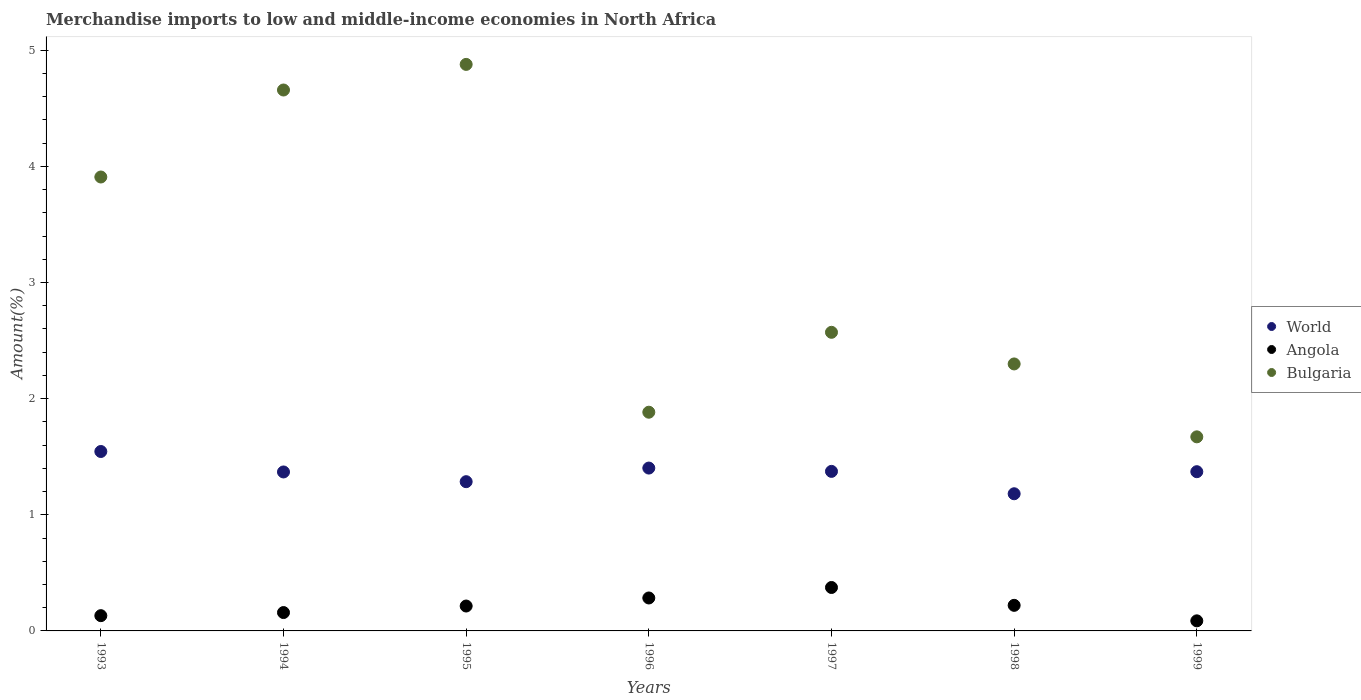Is the number of dotlines equal to the number of legend labels?
Keep it short and to the point. Yes. What is the percentage of amount earned from merchandise imports in Angola in 1993?
Your answer should be compact. 0.13. Across all years, what is the maximum percentage of amount earned from merchandise imports in Angola?
Keep it short and to the point. 0.37. Across all years, what is the minimum percentage of amount earned from merchandise imports in World?
Offer a terse response. 1.18. What is the total percentage of amount earned from merchandise imports in World in the graph?
Your answer should be compact. 9.53. What is the difference between the percentage of amount earned from merchandise imports in Bulgaria in 1998 and that in 1999?
Keep it short and to the point. 0.63. What is the difference between the percentage of amount earned from merchandise imports in Bulgaria in 1997 and the percentage of amount earned from merchandise imports in World in 1995?
Your response must be concise. 1.29. What is the average percentage of amount earned from merchandise imports in Bulgaria per year?
Your answer should be compact. 3.12. In the year 1994, what is the difference between the percentage of amount earned from merchandise imports in Angola and percentage of amount earned from merchandise imports in Bulgaria?
Provide a succinct answer. -4.5. In how many years, is the percentage of amount earned from merchandise imports in Angola greater than 1.6 %?
Your response must be concise. 0. What is the ratio of the percentage of amount earned from merchandise imports in Angola in 1994 to that in 1996?
Provide a succinct answer. 0.56. Is the difference between the percentage of amount earned from merchandise imports in Angola in 1994 and 1998 greater than the difference between the percentage of amount earned from merchandise imports in Bulgaria in 1994 and 1998?
Give a very brief answer. No. What is the difference between the highest and the second highest percentage of amount earned from merchandise imports in Angola?
Give a very brief answer. 0.09. What is the difference between the highest and the lowest percentage of amount earned from merchandise imports in Bulgaria?
Provide a short and direct response. 3.21. Is it the case that in every year, the sum of the percentage of amount earned from merchandise imports in World and percentage of amount earned from merchandise imports in Bulgaria  is greater than the percentage of amount earned from merchandise imports in Angola?
Provide a short and direct response. Yes. How many dotlines are there?
Make the answer very short. 3. How many years are there in the graph?
Offer a very short reply. 7. What is the difference between two consecutive major ticks on the Y-axis?
Provide a short and direct response. 1. Are the values on the major ticks of Y-axis written in scientific E-notation?
Make the answer very short. No. Where does the legend appear in the graph?
Your answer should be compact. Center right. How many legend labels are there?
Offer a terse response. 3. What is the title of the graph?
Your answer should be compact. Merchandise imports to low and middle-income economies in North Africa. What is the label or title of the Y-axis?
Ensure brevity in your answer.  Amount(%). What is the Amount(%) in World in 1993?
Ensure brevity in your answer.  1.54. What is the Amount(%) in Angola in 1993?
Make the answer very short. 0.13. What is the Amount(%) in Bulgaria in 1993?
Offer a terse response. 3.91. What is the Amount(%) of World in 1994?
Provide a short and direct response. 1.37. What is the Amount(%) of Angola in 1994?
Offer a terse response. 0.16. What is the Amount(%) in Bulgaria in 1994?
Provide a short and direct response. 4.66. What is the Amount(%) of World in 1995?
Your answer should be compact. 1.29. What is the Amount(%) of Angola in 1995?
Your response must be concise. 0.21. What is the Amount(%) of Bulgaria in 1995?
Your response must be concise. 4.88. What is the Amount(%) of World in 1996?
Your answer should be very brief. 1.4. What is the Amount(%) in Angola in 1996?
Offer a very short reply. 0.28. What is the Amount(%) of Bulgaria in 1996?
Make the answer very short. 1.88. What is the Amount(%) of World in 1997?
Your answer should be very brief. 1.37. What is the Amount(%) of Angola in 1997?
Your response must be concise. 0.37. What is the Amount(%) in Bulgaria in 1997?
Your response must be concise. 2.57. What is the Amount(%) in World in 1998?
Provide a succinct answer. 1.18. What is the Amount(%) in Angola in 1998?
Provide a succinct answer. 0.22. What is the Amount(%) in Bulgaria in 1998?
Offer a very short reply. 2.3. What is the Amount(%) in World in 1999?
Ensure brevity in your answer.  1.37. What is the Amount(%) in Angola in 1999?
Provide a short and direct response. 0.09. What is the Amount(%) of Bulgaria in 1999?
Your answer should be compact. 1.67. Across all years, what is the maximum Amount(%) of World?
Your response must be concise. 1.54. Across all years, what is the maximum Amount(%) of Angola?
Offer a terse response. 0.37. Across all years, what is the maximum Amount(%) of Bulgaria?
Your answer should be compact. 4.88. Across all years, what is the minimum Amount(%) in World?
Offer a very short reply. 1.18. Across all years, what is the minimum Amount(%) in Angola?
Give a very brief answer. 0.09. Across all years, what is the minimum Amount(%) in Bulgaria?
Provide a short and direct response. 1.67. What is the total Amount(%) in World in the graph?
Make the answer very short. 9.53. What is the total Amount(%) of Angola in the graph?
Your answer should be compact. 1.47. What is the total Amount(%) in Bulgaria in the graph?
Offer a very short reply. 21.87. What is the difference between the Amount(%) in World in 1993 and that in 1994?
Offer a very short reply. 0.18. What is the difference between the Amount(%) in Angola in 1993 and that in 1994?
Make the answer very short. -0.03. What is the difference between the Amount(%) of Bulgaria in 1993 and that in 1994?
Make the answer very short. -0.75. What is the difference between the Amount(%) of World in 1993 and that in 1995?
Your response must be concise. 0.26. What is the difference between the Amount(%) in Angola in 1993 and that in 1995?
Offer a very short reply. -0.08. What is the difference between the Amount(%) of Bulgaria in 1993 and that in 1995?
Make the answer very short. -0.97. What is the difference between the Amount(%) in World in 1993 and that in 1996?
Your answer should be very brief. 0.14. What is the difference between the Amount(%) in Angola in 1993 and that in 1996?
Give a very brief answer. -0.15. What is the difference between the Amount(%) in Bulgaria in 1993 and that in 1996?
Provide a short and direct response. 2.03. What is the difference between the Amount(%) of World in 1993 and that in 1997?
Give a very brief answer. 0.17. What is the difference between the Amount(%) of Angola in 1993 and that in 1997?
Give a very brief answer. -0.24. What is the difference between the Amount(%) of Bulgaria in 1993 and that in 1997?
Your answer should be very brief. 1.34. What is the difference between the Amount(%) in World in 1993 and that in 1998?
Ensure brevity in your answer.  0.36. What is the difference between the Amount(%) of Angola in 1993 and that in 1998?
Offer a terse response. -0.09. What is the difference between the Amount(%) in Bulgaria in 1993 and that in 1998?
Your answer should be very brief. 1.61. What is the difference between the Amount(%) in World in 1993 and that in 1999?
Ensure brevity in your answer.  0.17. What is the difference between the Amount(%) of Angola in 1993 and that in 1999?
Offer a terse response. 0.04. What is the difference between the Amount(%) of Bulgaria in 1993 and that in 1999?
Your answer should be very brief. 2.24. What is the difference between the Amount(%) of World in 1994 and that in 1995?
Provide a short and direct response. 0.08. What is the difference between the Amount(%) in Angola in 1994 and that in 1995?
Your response must be concise. -0.06. What is the difference between the Amount(%) of Bulgaria in 1994 and that in 1995?
Your answer should be compact. -0.22. What is the difference between the Amount(%) in World in 1994 and that in 1996?
Provide a succinct answer. -0.03. What is the difference between the Amount(%) of Angola in 1994 and that in 1996?
Your answer should be very brief. -0.13. What is the difference between the Amount(%) in Bulgaria in 1994 and that in 1996?
Give a very brief answer. 2.77. What is the difference between the Amount(%) in World in 1994 and that in 1997?
Offer a terse response. -0.01. What is the difference between the Amount(%) of Angola in 1994 and that in 1997?
Your answer should be compact. -0.22. What is the difference between the Amount(%) of Bulgaria in 1994 and that in 1997?
Your answer should be compact. 2.09. What is the difference between the Amount(%) in World in 1994 and that in 1998?
Ensure brevity in your answer.  0.19. What is the difference between the Amount(%) of Angola in 1994 and that in 1998?
Make the answer very short. -0.06. What is the difference between the Amount(%) of Bulgaria in 1994 and that in 1998?
Provide a succinct answer. 2.36. What is the difference between the Amount(%) of World in 1994 and that in 1999?
Give a very brief answer. -0. What is the difference between the Amount(%) in Angola in 1994 and that in 1999?
Your answer should be very brief. 0.07. What is the difference between the Amount(%) in Bulgaria in 1994 and that in 1999?
Offer a terse response. 2.99. What is the difference between the Amount(%) of World in 1995 and that in 1996?
Your answer should be very brief. -0.12. What is the difference between the Amount(%) in Angola in 1995 and that in 1996?
Your response must be concise. -0.07. What is the difference between the Amount(%) in Bulgaria in 1995 and that in 1996?
Your answer should be compact. 2.99. What is the difference between the Amount(%) of World in 1995 and that in 1997?
Provide a short and direct response. -0.09. What is the difference between the Amount(%) of Angola in 1995 and that in 1997?
Give a very brief answer. -0.16. What is the difference between the Amount(%) of Bulgaria in 1995 and that in 1997?
Give a very brief answer. 2.31. What is the difference between the Amount(%) of World in 1995 and that in 1998?
Offer a terse response. 0.1. What is the difference between the Amount(%) in Angola in 1995 and that in 1998?
Offer a terse response. -0.01. What is the difference between the Amount(%) in Bulgaria in 1995 and that in 1998?
Give a very brief answer. 2.58. What is the difference between the Amount(%) of World in 1995 and that in 1999?
Your response must be concise. -0.09. What is the difference between the Amount(%) in Angola in 1995 and that in 1999?
Keep it short and to the point. 0.13. What is the difference between the Amount(%) in Bulgaria in 1995 and that in 1999?
Offer a terse response. 3.21. What is the difference between the Amount(%) in World in 1996 and that in 1997?
Your response must be concise. 0.03. What is the difference between the Amount(%) of Angola in 1996 and that in 1997?
Give a very brief answer. -0.09. What is the difference between the Amount(%) of Bulgaria in 1996 and that in 1997?
Give a very brief answer. -0.69. What is the difference between the Amount(%) in World in 1996 and that in 1998?
Provide a succinct answer. 0.22. What is the difference between the Amount(%) of Angola in 1996 and that in 1998?
Provide a short and direct response. 0.06. What is the difference between the Amount(%) in Bulgaria in 1996 and that in 1998?
Your answer should be compact. -0.42. What is the difference between the Amount(%) of World in 1996 and that in 1999?
Provide a succinct answer. 0.03. What is the difference between the Amount(%) of Angola in 1996 and that in 1999?
Give a very brief answer. 0.2. What is the difference between the Amount(%) of Bulgaria in 1996 and that in 1999?
Keep it short and to the point. 0.21. What is the difference between the Amount(%) of World in 1997 and that in 1998?
Keep it short and to the point. 0.19. What is the difference between the Amount(%) in Angola in 1997 and that in 1998?
Provide a succinct answer. 0.15. What is the difference between the Amount(%) in Bulgaria in 1997 and that in 1998?
Make the answer very short. 0.27. What is the difference between the Amount(%) in World in 1997 and that in 1999?
Your answer should be compact. 0. What is the difference between the Amount(%) of Angola in 1997 and that in 1999?
Your response must be concise. 0.29. What is the difference between the Amount(%) in Bulgaria in 1997 and that in 1999?
Your answer should be compact. 0.9. What is the difference between the Amount(%) in World in 1998 and that in 1999?
Offer a terse response. -0.19. What is the difference between the Amount(%) of Angola in 1998 and that in 1999?
Offer a very short reply. 0.13. What is the difference between the Amount(%) of Bulgaria in 1998 and that in 1999?
Make the answer very short. 0.63. What is the difference between the Amount(%) of World in 1993 and the Amount(%) of Angola in 1994?
Ensure brevity in your answer.  1.39. What is the difference between the Amount(%) in World in 1993 and the Amount(%) in Bulgaria in 1994?
Ensure brevity in your answer.  -3.11. What is the difference between the Amount(%) in Angola in 1993 and the Amount(%) in Bulgaria in 1994?
Your answer should be compact. -4.53. What is the difference between the Amount(%) of World in 1993 and the Amount(%) of Angola in 1995?
Ensure brevity in your answer.  1.33. What is the difference between the Amount(%) of World in 1993 and the Amount(%) of Bulgaria in 1995?
Your response must be concise. -3.33. What is the difference between the Amount(%) in Angola in 1993 and the Amount(%) in Bulgaria in 1995?
Offer a terse response. -4.75. What is the difference between the Amount(%) of World in 1993 and the Amount(%) of Angola in 1996?
Give a very brief answer. 1.26. What is the difference between the Amount(%) in World in 1993 and the Amount(%) in Bulgaria in 1996?
Ensure brevity in your answer.  -0.34. What is the difference between the Amount(%) of Angola in 1993 and the Amount(%) of Bulgaria in 1996?
Ensure brevity in your answer.  -1.75. What is the difference between the Amount(%) of World in 1993 and the Amount(%) of Angola in 1997?
Give a very brief answer. 1.17. What is the difference between the Amount(%) of World in 1993 and the Amount(%) of Bulgaria in 1997?
Offer a terse response. -1.03. What is the difference between the Amount(%) in Angola in 1993 and the Amount(%) in Bulgaria in 1997?
Give a very brief answer. -2.44. What is the difference between the Amount(%) in World in 1993 and the Amount(%) in Angola in 1998?
Provide a short and direct response. 1.32. What is the difference between the Amount(%) of World in 1993 and the Amount(%) of Bulgaria in 1998?
Make the answer very short. -0.75. What is the difference between the Amount(%) of Angola in 1993 and the Amount(%) of Bulgaria in 1998?
Your response must be concise. -2.17. What is the difference between the Amount(%) in World in 1993 and the Amount(%) in Angola in 1999?
Your response must be concise. 1.46. What is the difference between the Amount(%) in World in 1993 and the Amount(%) in Bulgaria in 1999?
Offer a terse response. -0.13. What is the difference between the Amount(%) of Angola in 1993 and the Amount(%) of Bulgaria in 1999?
Offer a very short reply. -1.54. What is the difference between the Amount(%) of World in 1994 and the Amount(%) of Angola in 1995?
Offer a very short reply. 1.15. What is the difference between the Amount(%) of World in 1994 and the Amount(%) of Bulgaria in 1995?
Make the answer very short. -3.51. What is the difference between the Amount(%) of Angola in 1994 and the Amount(%) of Bulgaria in 1995?
Provide a short and direct response. -4.72. What is the difference between the Amount(%) of World in 1994 and the Amount(%) of Angola in 1996?
Keep it short and to the point. 1.09. What is the difference between the Amount(%) in World in 1994 and the Amount(%) in Bulgaria in 1996?
Your answer should be very brief. -0.51. What is the difference between the Amount(%) in Angola in 1994 and the Amount(%) in Bulgaria in 1996?
Your answer should be very brief. -1.73. What is the difference between the Amount(%) in World in 1994 and the Amount(%) in Bulgaria in 1997?
Provide a succinct answer. -1.2. What is the difference between the Amount(%) in Angola in 1994 and the Amount(%) in Bulgaria in 1997?
Keep it short and to the point. -2.41. What is the difference between the Amount(%) of World in 1994 and the Amount(%) of Angola in 1998?
Make the answer very short. 1.15. What is the difference between the Amount(%) in World in 1994 and the Amount(%) in Bulgaria in 1998?
Provide a succinct answer. -0.93. What is the difference between the Amount(%) in Angola in 1994 and the Amount(%) in Bulgaria in 1998?
Offer a terse response. -2.14. What is the difference between the Amount(%) in World in 1994 and the Amount(%) in Angola in 1999?
Your answer should be very brief. 1.28. What is the difference between the Amount(%) of World in 1994 and the Amount(%) of Bulgaria in 1999?
Give a very brief answer. -0.3. What is the difference between the Amount(%) of Angola in 1994 and the Amount(%) of Bulgaria in 1999?
Keep it short and to the point. -1.51. What is the difference between the Amount(%) in World in 1995 and the Amount(%) in Angola in 1996?
Ensure brevity in your answer.  1. What is the difference between the Amount(%) of World in 1995 and the Amount(%) of Bulgaria in 1996?
Your answer should be compact. -0.6. What is the difference between the Amount(%) in Angola in 1995 and the Amount(%) in Bulgaria in 1996?
Provide a short and direct response. -1.67. What is the difference between the Amount(%) in World in 1995 and the Amount(%) in Angola in 1997?
Give a very brief answer. 0.91. What is the difference between the Amount(%) of World in 1995 and the Amount(%) of Bulgaria in 1997?
Offer a terse response. -1.29. What is the difference between the Amount(%) of Angola in 1995 and the Amount(%) of Bulgaria in 1997?
Your answer should be compact. -2.36. What is the difference between the Amount(%) of World in 1995 and the Amount(%) of Angola in 1998?
Provide a succinct answer. 1.06. What is the difference between the Amount(%) in World in 1995 and the Amount(%) in Bulgaria in 1998?
Give a very brief answer. -1.01. What is the difference between the Amount(%) in Angola in 1995 and the Amount(%) in Bulgaria in 1998?
Your answer should be very brief. -2.08. What is the difference between the Amount(%) in World in 1995 and the Amount(%) in Angola in 1999?
Provide a succinct answer. 1.2. What is the difference between the Amount(%) of World in 1995 and the Amount(%) of Bulgaria in 1999?
Keep it short and to the point. -0.39. What is the difference between the Amount(%) in Angola in 1995 and the Amount(%) in Bulgaria in 1999?
Provide a succinct answer. -1.46. What is the difference between the Amount(%) in World in 1996 and the Amount(%) in Angola in 1997?
Provide a short and direct response. 1.03. What is the difference between the Amount(%) in World in 1996 and the Amount(%) in Bulgaria in 1997?
Ensure brevity in your answer.  -1.17. What is the difference between the Amount(%) in Angola in 1996 and the Amount(%) in Bulgaria in 1997?
Offer a very short reply. -2.29. What is the difference between the Amount(%) of World in 1996 and the Amount(%) of Angola in 1998?
Make the answer very short. 1.18. What is the difference between the Amount(%) of World in 1996 and the Amount(%) of Bulgaria in 1998?
Give a very brief answer. -0.9. What is the difference between the Amount(%) of Angola in 1996 and the Amount(%) of Bulgaria in 1998?
Keep it short and to the point. -2.02. What is the difference between the Amount(%) in World in 1996 and the Amount(%) in Angola in 1999?
Your answer should be very brief. 1.32. What is the difference between the Amount(%) in World in 1996 and the Amount(%) in Bulgaria in 1999?
Ensure brevity in your answer.  -0.27. What is the difference between the Amount(%) in Angola in 1996 and the Amount(%) in Bulgaria in 1999?
Your answer should be very brief. -1.39. What is the difference between the Amount(%) in World in 1997 and the Amount(%) in Angola in 1998?
Offer a terse response. 1.15. What is the difference between the Amount(%) of World in 1997 and the Amount(%) of Bulgaria in 1998?
Make the answer very short. -0.93. What is the difference between the Amount(%) of Angola in 1997 and the Amount(%) of Bulgaria in 1998?
Provide a succinct answer. -1.92. What is the difference between the Amount(%) in World in 1997 and the Amount(%) in Angola in 1999?
Provide a succinct answer. 1.29. What is the difference between the Amount(%) in World in 1997 and the Amount(%) in Bulgaria in 1999?
Make the answer very short. -0.3. What is the difference between the Amount(%) of Angola in 1997 and the Amount(%) of Bulgaria in 1999?
Provide a short and direct response. -1.3. What is the difference between the Amount(%) in World in 1998 and the Amount(%) in Angola in 1999?
Give a very brief answer. 1.09. What is the difference between the Amount(%) in World in 1998 and the Amount(%) in Bulgaria in 1999?
Make the answer very short. -0.49. What is the difference between the Amount(%) of Angola in 1998 and the Amount(%) of Bulgaria in 1999?
Your answer should be compact. -1.45. What is the average Amount(%) in World per year?
Make the answer very short. 1.36. What is the average Amount(%) of Angola per year?
Offer a terse response. 0.21. What is the average Amount(%) of Bulgaria per year?
Your answer should be very brief. 3.12. In the year 1993, what is the difference between the Amount(%) in World and Amount(%) in Angola?
Ensure brevity in your answer.  1.41. In the year 1993, what is the difference between the Amount(%) of World and Amount(%) of Bulgaria?
Your answer should be very brief. -2.36. In the year 1993, what is the difference between the Amount(%) in Angola and Amount(%) in Bulgaria?
Your response must be concise. -3.78. In the year 1994, what is the difference between the Amount(%) in World and Amount(%) in Angola?
Give a very brief answer. 1.21. In the year 1994, what is the difference between the Amount(%) in World and Amount(%) in Bulgaria?
Offer a terse response. -3.29. In the year 1994, what is the difference between the Amount(%) of Angola and Amount(%) of Bulgaria?
Provide a short and direct response. -4.5. In the year 1995, what is the difference between the Amount(%) in World and Amount(%) in Angola?
Make the answer very short. 1.07. In the year 1995, what is the difference between the Amount(%) of World and Amount(%) of Bulgaria?
Ensure brevity in your answer.  -3.59. In the year 1995, what is the difference between the Amount(%) of Angola and Amount(%) of Bulgaria?
Offer a very short reply. -4.66. In the year 1996, what is the difference between the Amount(%) of World and Amount(%) of Angola?
Make the answer very short. 1.12. In the year 1996, what is the difference between the Amount(%) in World and Amount(%) in Bulgaria?
Your answer should be very brief. -0.48. In the year 1996, what is the difference between the Amount(%) in Angola and Amount(%) in Bulgaria?
Your answer should be compact. -1.6. In the year 1997, what is the difference between the Amount(%) in World and Amount(%) in Bulgaria?
Provide a succinct answer. -1.2. In the year 1997, what is the difference between the Amount(%) of Angola and Amount(%) of Bulgaria?
Your answer should be very brief. -2.2. In the year 1998, what is the difference between the Amount(%) of World and Amount(%) of Angola?
Ensure brevity in your answer.  0.96. In the year 1998, what is the difference between the Amount(%) in World and Amount(%) in Bulgaria?
Offer a very short reply. -1.12. In the year 1998, what is the difference between the Amount(%) of Angola and Amount(%) of Bulgaria?
Keep it short and to the point. -2.08. In the year 1999, what is the difference between the Amount(%) of World and Amount(%) of Angola?
Provide a succinct answer. 1.28. In the year 1999, what is the difference between the Amount(%) in World and Amount(%) in Bulgaria?
Keep it short and to the point. -0.3. In the year 1999, what is the difference between the Amount(%) in Angola and Amount(%) in Bulgaria?
Your response must be concise. -1.58. What is the ratio of the Amount(%) in World in 1993 to that in 1994?
Your answer should be very brief. 1.13. What is the ratio of the Amount(%) in Angola in 1993 to that in 1994?
Your response must be concise. 0.83. What is the ratio of the Amount(%) in Bulgaria in 1993 to that in 1994?
Keep it short and to the point. 0.84. What is the ratio of the Amount(%) of World in 1993 to that in 1995?
Your answer should be compact. 1.2. What is the ratio of the Amount(%) in Angola in 1993 to that in 1995?
Offer a very short reply. 0.61. What is the ratio of the Amount(%) of Bulgaria in 1993 to that in 1995?
Your answer should be very brief. 0.8. What is the ratio of the Amount(%) of World in 1993 to that in 1996?
Ensure brevity in your answer.  1.1. What is the ratio of the Amount(%) of Angola in 1993 to that in 1996?
Keep it short and to the point. 0.46. What is the ratio of the Amount(%) of Bulgaria in 1993 to that in 1996?
Give a very brief answer. 2.08. What is the ratio of the Amount(%) of World in 1993 to that in 1997?
Your answer should be very brief. 1.12. What is the ratio of the Amount(%) of Angola in 1993 to that in 1997?
Provide a succinct answer. 0.35. What is the ratio of the Amount(%) of Bulgaria in 1993 to that in 1997?
Offer a very short reply. 1.52. What is the ratio of the Amount(%) in World in 1993 to that in 1998?
Offer a very short reply. 1.31. What is the ratio of the Amount(%) in Angola in 1993 to that in 1998?
Your answer should be very brief. 0.6. What is the ratio of the Amount(%) of Bulgaria in 1993 to that in 1998?
Your response must be concise. 1.7. What is the ratio of the Amount(%) in World in 1993 to that in 1999?
Offer a very short reply. 1.13. What is the ratio of the Amount(%) of Angola in 1993 to that in 1999?
Make the answer very short. 1.51. What is the ratio of the Amount(%) in Bulgaria in 1993 to that in 1999?
Provide a short and direct response. 2.34. What is the ratio of the Amount(%) of World in 1994 to that in 1995?
Offer a very short reply. 1.07. What is the ratio of the Amount(%) of Angola in 1994 to that in 1995?
Provide a succinct answer. 0.74. What is the ratio of the Amount(%) of Bulgaria in 1994 to that in 1995?
Give a very brief answer. 0.95. What is the ratio of the Amount(%) in World in 1994 to that in 1996?
Offer a terse response. 0.98. What is the ratio of the Amount(%) of Angola in 1994 to that in 1996?
Provide a succinct answer. 0.56. What is the ratio of the Amount(%) of Bulgaria in 1994 to that in 1996?
Keep it short and to the point. 2.47. What is the ratio of the Amount(%) in World in 1994 to that in 1997?
Give a very brief answer. 1. What is the ratio of the Amount(%) of Angola in 1994 to that in 1997?
Give a very brief answer. 0.42. What is the ratio of the Amount(%) in Bulgaria in 1994 to that in 1997?
Give a very brief answer. 1.81. What is the ratio of the Amount(%) of World in 1994 to that in 1998?
Provide a succinct answer. 1.16. What is the ratio of the Amount(%) of Angola in 1994 to that in 1998?
Ensure brevity in your answer.  0.72. What is the ratio of the Amount(%) of Bulgaria in 1994 to that in 1998?
Ensure brevity in your answer.  2.03. What is the ratio of the Amount(%) in Angola in 1994 to that in 1999?
Your answer should be very brief. 1.82. What is the ratio of the Amount(%) of Bulgaria in 1994 to that in 1999?
Give a very brief answer. 2.79. What is the ratio of the Amount(%) in World in 1995 to that in 1996?
Make the answer very short. 0.92. What is the ratio of the Amount(%) of Angola in 1995 to that in 1996?
Make the answer very short. 0.76. What is the ratio of the Amount(%) of Bulgaria in 1995 to that in 1996?
Make the answer very short. 2.59. What is the ratio of the Amount(%) of World in 1995 to that in 1997?
Your answer should be compact. 0.94. What is the ratio of the Amount(%) of Angola in 1995 to that in 1997?
Keep it short and to the point. 0.57. What is the ratio of the Amount(%) in Bulgaria in 1995 to that in 1997?
Your answer should be compact. 1.9. What is the ratio of the Amount(%) of World in 1995 to that in 1998?
Keep it short and to the point. 1.09. What is the ratio of the Amount(%) in Angola in 1995 to that in 1998?
Give a very brief answer. 0.97. What is the ratio of the Amount(%) in Bulgaria in 1995 to that in 1998?
Your response must be concise. 2.12. What is the ratio of the Amount(%) of World in 1995 to that in 1999?
Offer a terse response. 0.94. What is the ratio of the Amount(%) in Angola in 1995 to that in 1999?
Keep it short and to the point. 2.47. What is the ratio of the Amount(%) in Bulgaria in 1995 to that in 1999?
Ensure brevity in your answer.  2.92. What is the ratio of the Amount(%) in World in 1996 to that in 1997?
Ensure brevity in your answer.  1.02. What is the ratio of the Amount(%) in Angola in 1996 to that in 1997?
Offer a very short reply. 0.76. What is the ratio of the Amount(%) in Bulgaria in 1996 to that in 1997?
Offer a very short reply. 0.73. What is the ratio of the Amount(%) in World in 1996 to that in 1998?
Offer a terse response. 1.19. What is the ratio of the Amount(%) of Angola in 1996 to that in 1998?
Give a very brief answer. 1.29. What is the ratio of the Amount(%) of Bulgaria in 1996 to that in 1998?
Make the answer very short. 0.82. What is the ratio of the Amount(%) of World in 1996 to that in 1999?
Make the answer very short. 1.02. What is the ratio of the Amount(%) in Angola in 1996 to that in 1999?
Give a very brief answer. 3.27. What is the ratio of the Amount(%) of Bulgaria in 1996 to that in 1999?
Keep it short and to the point. 1.13. What is the ratio of the Amount(%) of World in 1997 to that in 1998?
Make the answer very short. 1.16. What is the ratio of the Amount(%) in Angola in 1997 to that in 1998?
Your answer should be compact. 1.7. What is the ratio of the Amount(%) in Bulgaria in 1997 to that in 1998?
Keep it short and to the point. 1.12. What is the ratio of the Amount(%) of World in 1997 to that in 1999?
Make the answer very short. 1. What is the ratio of the Amount(%) in Angola in 1997 to that in 1999?
Keep it short and to the point. 4.31. What is the ratio of the Amount(%) in Bulgaria in 1997 to that in 1999?
Ensure brevity in your answer.  1.54. What is the ratio of the Amount(%) in World in 1998 to that in 1999?
Your response must be concise. 0.86. What is the ratio of the Amount(%) in Angola in 1998 to that in 1999?
Ensure brevity in your answer.  2.54. What is the ratio of the Amount(%) in Bulgaria in 1998 to that in 1999?
Keep it short and to the point. 1.38. What is the difference between the highest and the second highest Amount(%) in World?
Make the answer very short. 0.14. What is the difference between the highest and the second highest Amount(%) of Angola?
Provide a succinct answer. 0.09. What is the difference between the highest and the second highest Amount(%) in Bulgaria?
Offer a terse response. 0.22. What is the difference between the highest and the lowest Amount(%) of World?
Provide a succinct answer. 0.36. What is the difference between the highest and the lowest Amount(%) in Angola?
Provide a short and direct response. 0.29. What is the difference between the highest and the lowest Amount(%) of Bulgaria?
Your answer should be very brief. 3.21. 